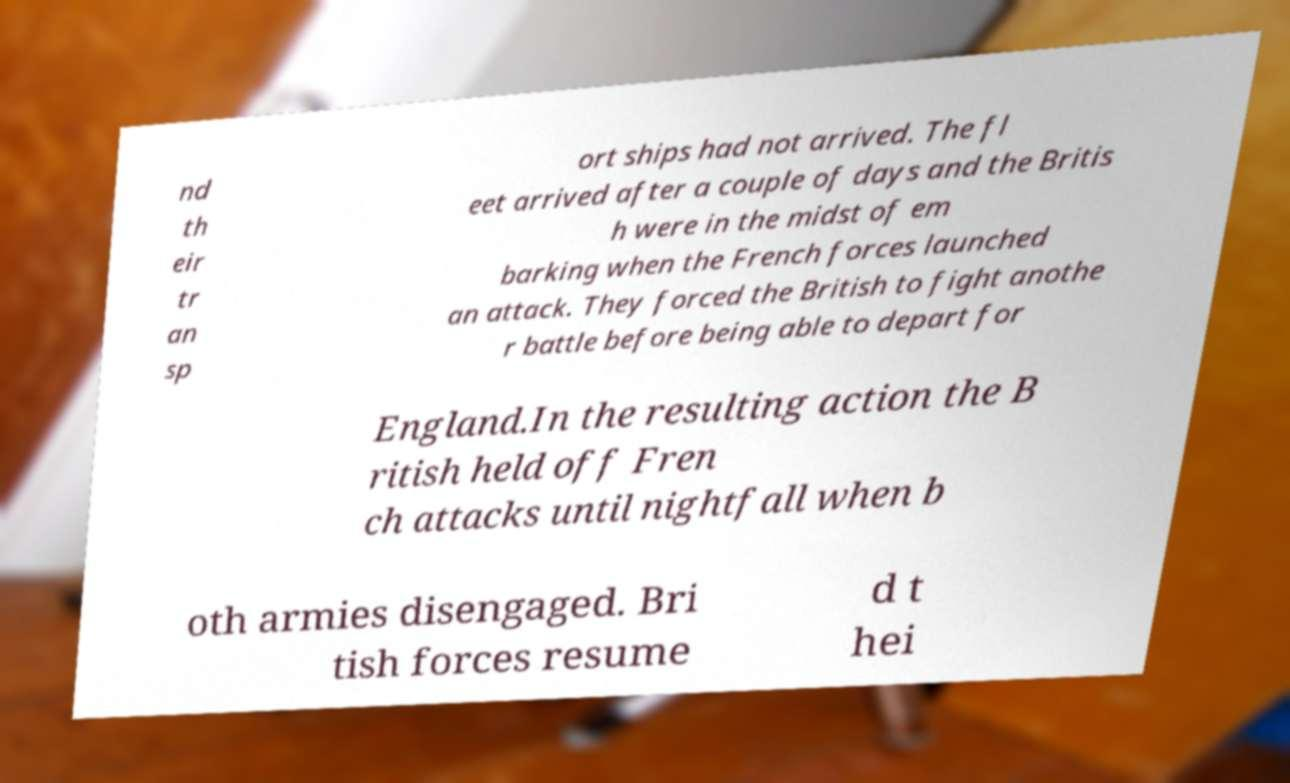Could you extract and type out the text from this image? nd th eir tr an sp ort ships had not arrived. The fl eet arrived after a couple of days and the Britis h were in the midst of em barking when the French forces launched an attack. They forced the British to fight anothe r battle before being able to depart for England.In the resulting action the B ritish held off Fren ch attacks until nightfall when b oth armies disengaged. Bri tish forces resume d t hei 